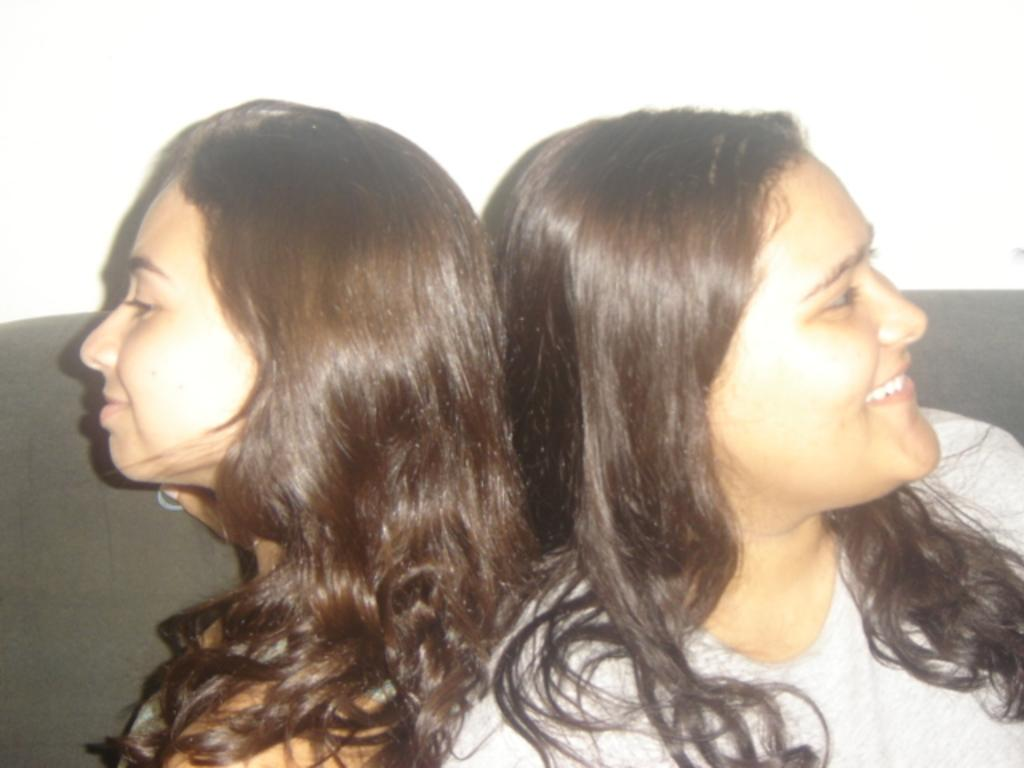Who is present in the image? There are women in the image. What are the women doing in the image? The women are sitting. Can you describe the facial expression of one of the women? One of the women is smiling. What type of notebook is the woman holding in the image? There is no notebook present in the image. What is the current temperature in the image? The image does not provide information about the temperature. 